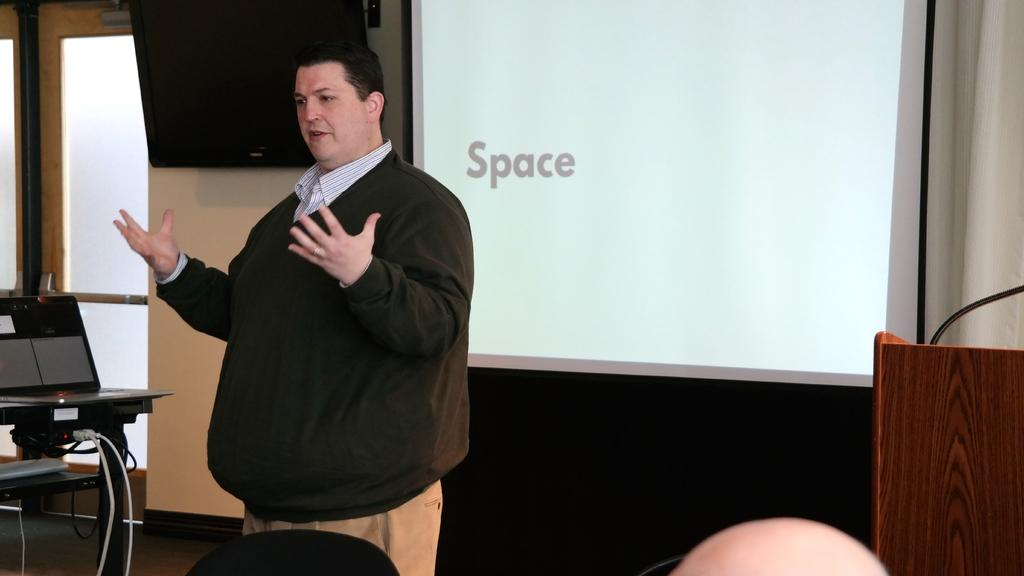What is the man in the image doing? There is a man standing in the image. What electronic device can be seen in the image? There is a laptop in the image. What else is visible in the image besides the laptop? There are wires visible in the image. What can be seen in the background of the image? There is a wall, a TV, a screen, and a podium in the background of the image. Can you see any ducks flying in the image? There are no ducks or any indication of flight present in the image. Is there a party happening in the background of the image? There is no indication of a party or any social gathering in the image. 